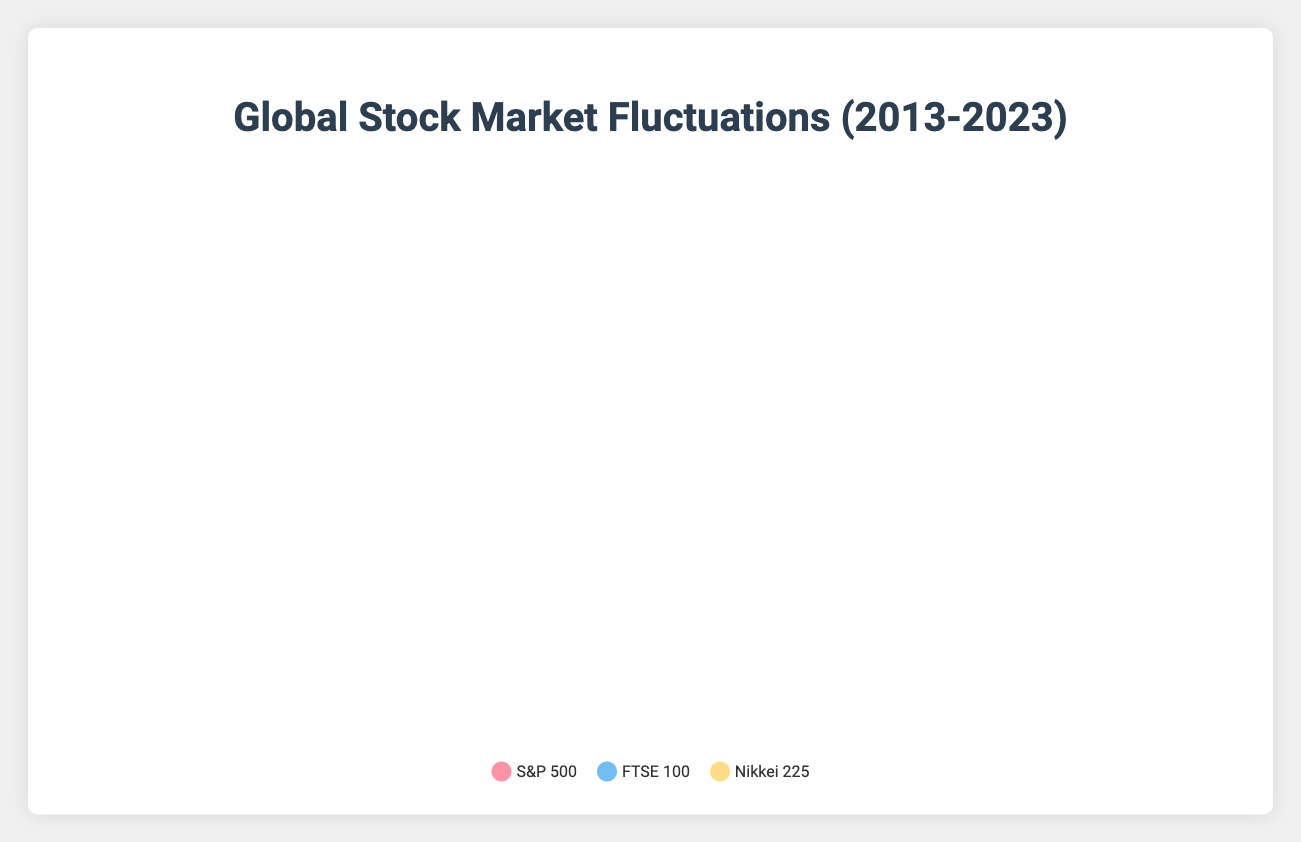What year did all three stock markets (S&P 500, FTSE 100, and Nikkei 225) see a decline? Looking at the plot, identify the years when all three stock indices show negative percentage changes. The years 2013, 2016, 2018, 2020, 2022, and 2023 exhibit declines in all three indices as depicted by the downward sloping curves.
Answer: 2013, 2016, 2018, 2020, 2022, 2023 Which year's event led to the largest decline in the S&P 500? Observe the points on the S&P 500 curve and identify the maximum negative percentage change. The largest decline in the S&P 500 was approximately -20% in 2020, attributed to the COVID-19 Pandemic.
Answer: 2020 What is the average percentage change in the FTSE 100 for the years when the interest rate increased? Identify and select the years when the interest rate increased (2017, 2022, 2023), then calculate the average of the FTSE 100 percentage changes for those years. The FTSE 100 changes are 0.98, -4.11, and -6.89. The average is (0.98 - 4.11 - 6.89) / 3 = -3.34%.
Answer: -3.34% Compare the stock market performances during the US Federal Reserve Rate Hikes in 2017 and 2022. Which year saw worse overall stock market performance? Compare the percentage changes in the S&P 500, FTSE 100, and Nikkei 225 between 2017 and 2022. In 2017, the changes were 1.42, 0.98, and 1.26, respectively. In 2022, the changes were -5.14, -4.11, and -6.26, respectively. All indices performed worse in 2022 compared to 2017, denoting poorer overall stock market performance in 2022.
Answer: 2022 What trends can be observed in the Nikkei 225 percentage changes during the years with decreased interest rates? Check the plot segments corresponding to the years with decreased interest rates (2015, 2016, 2019, 2020) and note the pattern of the changes in the Nikkei 225. In 2015 it increased by 1.82%, decreased by 7.92% in 2016, increased by 3.15% in 2019, and decreased by 18.91% in 2020.
Answer: Mixed trends with both increases and decreases During the Economic Recovery Post-COVID in 2021, which index showed the highest percentage growth? Locate the 2021 data points for all three indices (S&P 500, FTSE 100, Nikkei 225) and compare their percentage changes. The S&P 500 increased by 16.26%, FTSE 100 by 9.34%, and Nikkei 225 by 16.01%. The S&P 500 showed the highest percentage growth.
Answer: S&P 500 Calculate the total percentage change in the Nikkei 225 from 2020 to 2023. Sum up the percentage changes in the Nikkei 225 for the years 2020, 2021, 2022, and 2023. The changes are -18.91%, 16.01%, -6.26%, and -5.35%, respectively. Total change = (-18.91 + 16.01 - 6.26 - 5.35) = -14.51%.
Answer: -14.51% Which year had the smallest decline in the FTSE 100 during a crisis event? Identify the crisis events and their corresponding years, then find the year with the smallest negative percentage change in the FTSE 100. The relevant years are 2013, 2016, 2018, 2020, 2022, and 2023. Comparing values: -1.88% (2013), -5.62% (2016), -5.53% (2018), -24.69% (2020), -4.11% (2022), -6.89% (2023). The smallest decline occurred in 2013.
Answer: 2013 